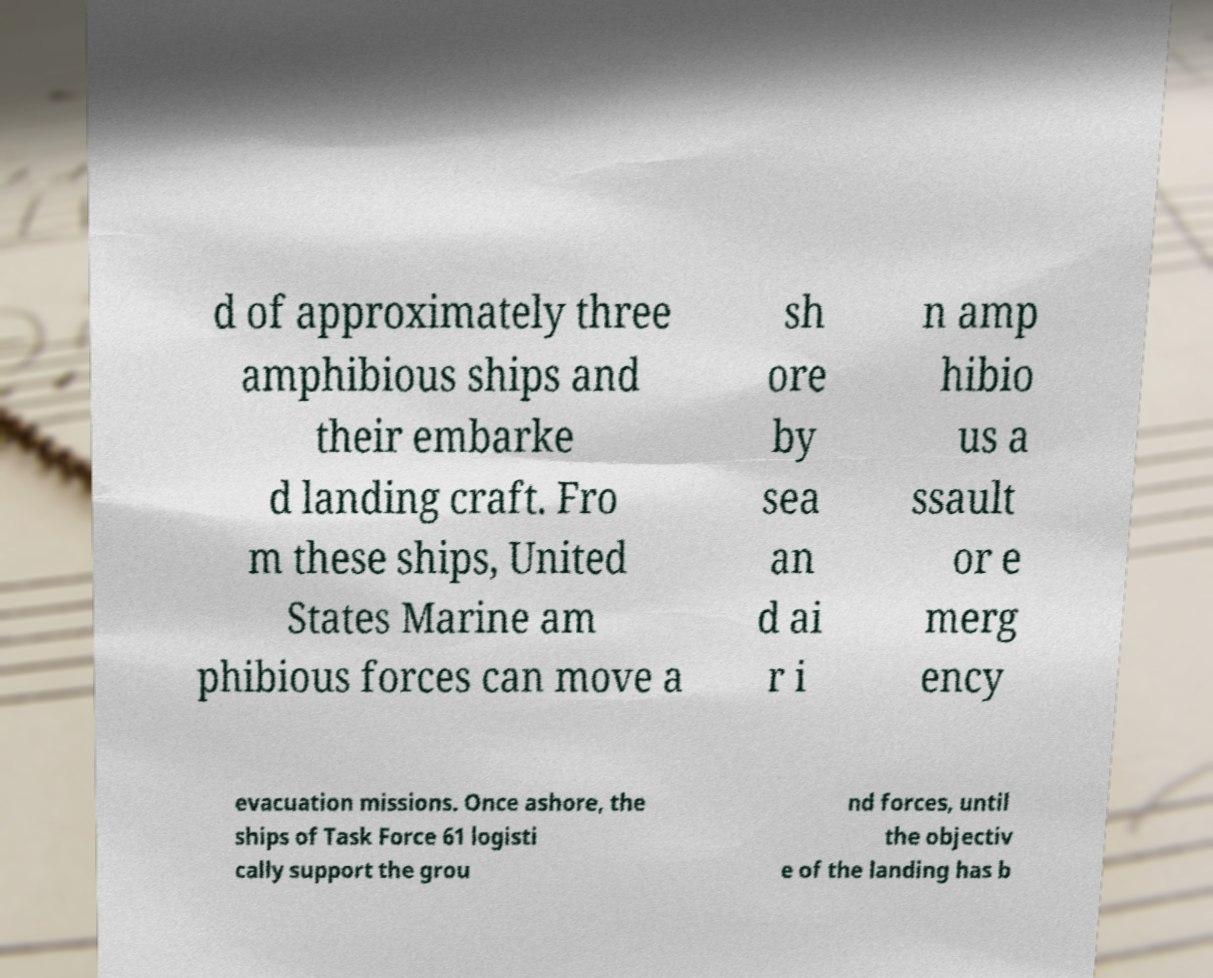I need the written content from this picture converted into text. Can you do that? d of approximately three amphibious ships and their embarke d landing craft. Fro m these ships, United States Marine am phibious forces can move a sh ore by sea an d ai r i n amp hibio us a ssault or e merg ency evacuation missions. Once ashore, the ships of Task Force 61 logisti cally support the grou nd forces, until the objectiv e of the landing has b 